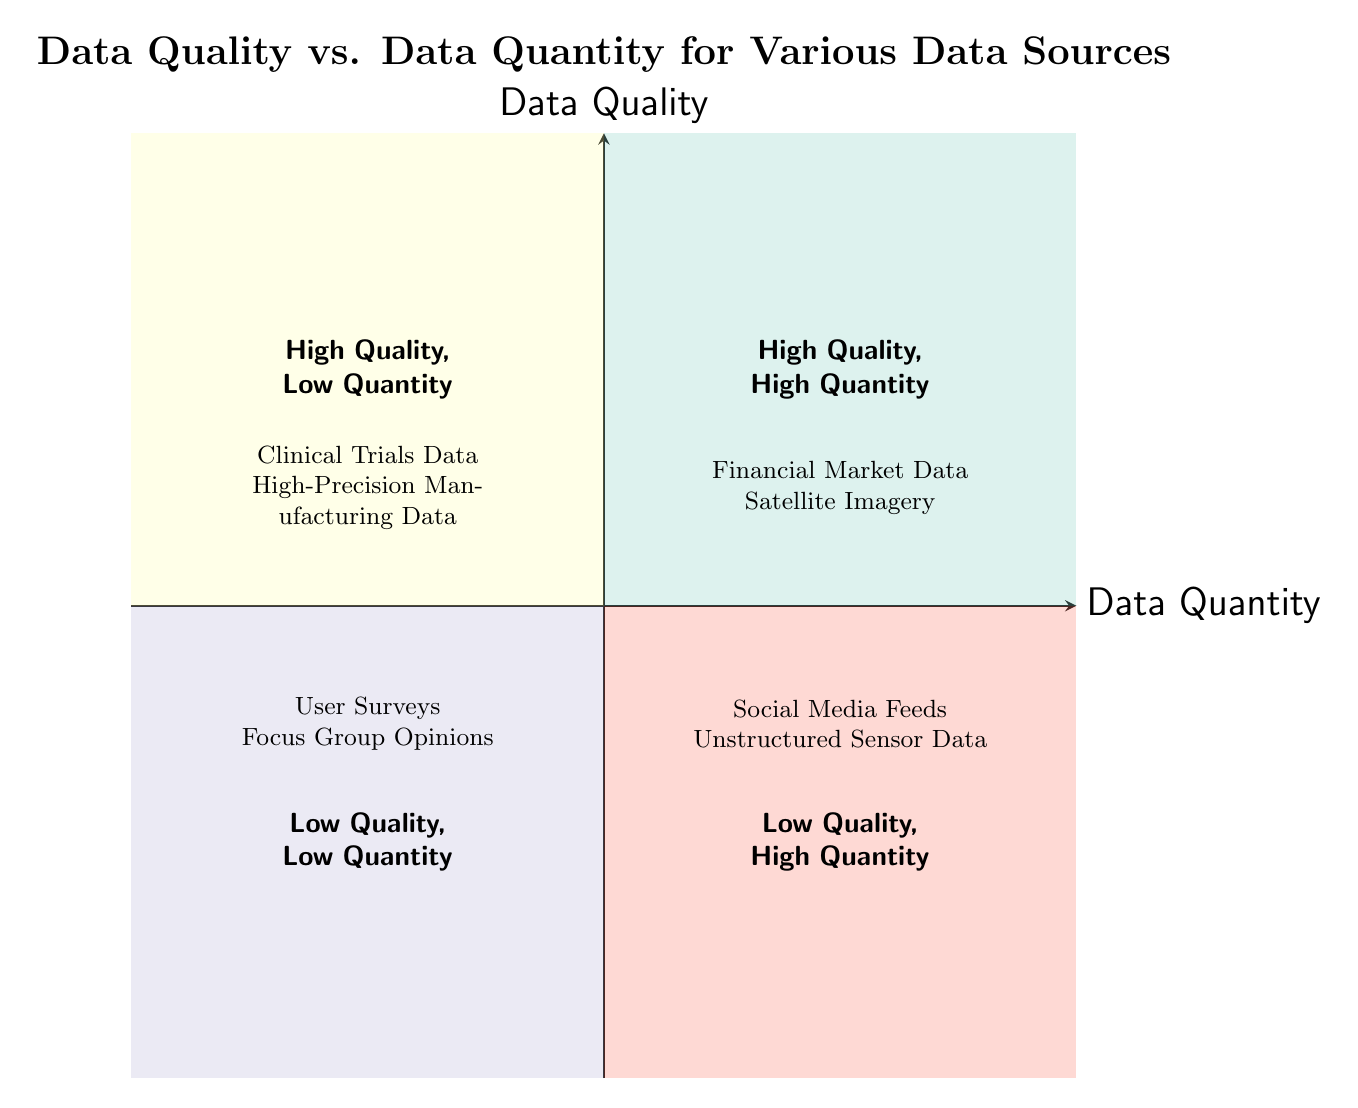What are the examples in the High Quality, High Quantity quadrant? To answer this, we need to locate the section of the diagram labeled "High Quality, High Quantity," and find the examples listed there. The examples mentioned are "Financial Market Data" and "Satellite Imagery."
Answer: Financial Market Data, Satellite Imagery How many quadrants are in the diagram? The diagram is divided into four distinct sections, known as quadrants. By counting these sections visually, we confirm that there are four quadrants present.
Answer: Four Which quadrant contains User Surveys? User Surveys is mentioned as an example in the quadrant labeled "Low Quality, Low Quantity." By cross-referencing the location of User Surveys on the diagram, we can establish that this is where they are situated.
Answer: Low Quality, Low Quantity What type of data is shown in the Low Quality, High Quantity quadrant? We look for the quadrant labeled "Low Quality, High Quantity" and identify the examples provided in that section. The examples listed are "Social Media Feeds" and "Unstructured Sensor Data."
Answer: Social Media Feeds, Unstructured Sensor Data Which quadrant has only high quality data? The quadrants classified as having only high quality data are those labeled "High Quality, High Quantity" and "High Quality, Low Quantity." By affirming that both quadrants refer to high quality data, we recognize that each serves this criterion, but the question specifies only one. Therefore, the quadrant with high quality data highlighted predominantly in terms of quantity would be "High Quality, High Quantity."
Answer: High Quality, High Quantity Which type of data has low quality and low quantity? To determine this, we find the quadrant labeled "Low Quality, Low Quantity" and identify the examples listed. The examples given in this quadrant include "User Surveys" and "Focus Group Opinions."
Answer: User Surveys, Focus Group Opinions How is data quality measured in this diagram? The Y-axis of the diagram represents data quality, indicating that data quality is evaluated along this vertical axis. Looking at the associated quadrants, we can see how examples are categorized based on their quality levels.
Answer: Y-axis What does the X-axis represent? The X-axis of the chart shows data quantity, which is emphasized by the labeled axis at the bottom of the diagram. Thus, data quantity is assessed along this horizontal axis.
Answer: Data Quantity 